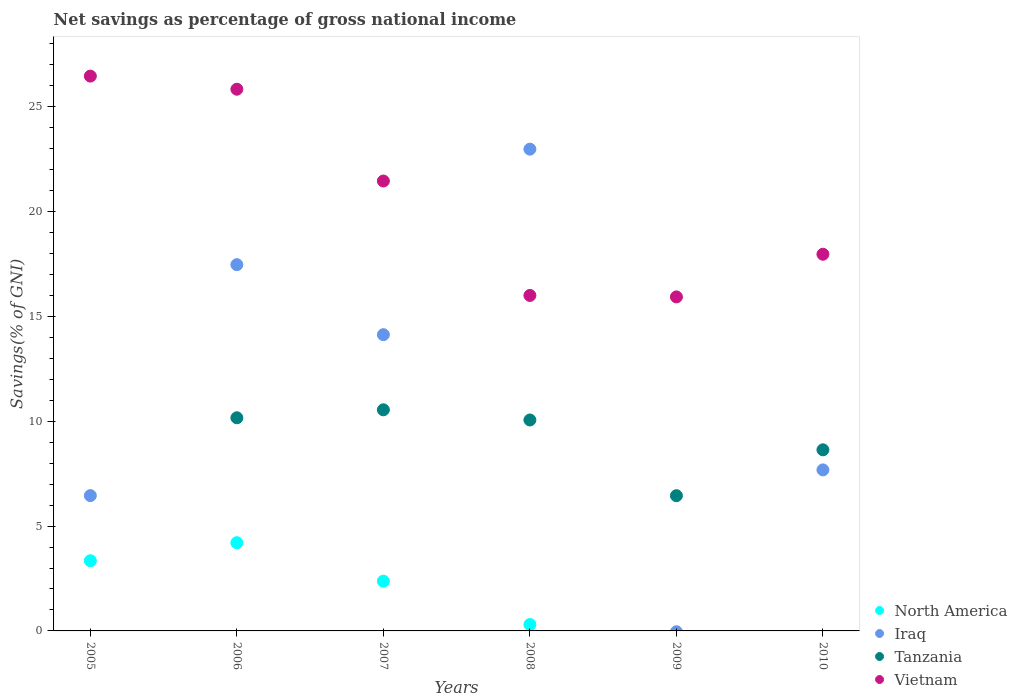What is the total savings in North America in 2007?
Give a very brief answer. 2.37. Across all years, what is the maximum total savings in Iraq?
Offer a very short reply. 22.98. Across all years, what is the minimum total savings in Vietnam?
Make the answer very short. 15.93. What is the total total savings in North America in the graph?
Your answer should be compact. 10.23. What is the difference between the total savings in Iraq in 2005 and that in 2006?
Offer a very short reply. -11.02. What is the difference between the total savings in Tanzania in 2005 and the total savings in Vietnam in 2007?
Keep it short and to the point. -21.46. What is the average total savings in North America per year?
Provide a succinct answer. 1.71. In the year 2006, what is the difference between the total savings in Tanzania and total savings in Vietnam?
Provide a succinct answer. -15.67. What is the ratio of the total savings in Vietnam in 2007 to that in 2008?
Give a very brief answer. 1.34. Is the total savings in Iraq in 2006 less than that in 2010?
Offer a terse response. No. What is the difference between the highest and the second highest total savings in Tanzania?
Your answer should be compact. 0.38. What is the difference between the highest and the lowest total savings in Iraq?
Provide a short and direct response. 22.98. In how many years, is the total savings in Vietnam greater than the average total savings in Vietnam taken over all years?
Your response must be concise. 3. Is it the case that in every year, the sum of the total savings in Vietnam and total savings in Iraq  is greater than the sum of total savings in Tanzania and total savings in North America?
Ensure brevity in your answer.  No. Is it the case that in every year, the sum of the total savings in Iraq and total savings in Vietnam  is greater than the total savings in Tanzania?
Offer a terse response. Yes. Is the total savings in Tanzania strictly less than the total savings in Vietnam over the years?
Your answer should be compact. Yes. How many years are there in the graph?
Give a very brief answer. 6. Does the graph contain any zero values?
Ensure brevity in your answer.  Yes. Does the graph contain grids?
Keep it short and to the point. No. How many legend labels are there?
Provide a succinct answer. 4. How are the legend labels stacked?
Provide a short and direct response. Vertical. What is the title of the graph?
Your answer should be very brief. Net savings as percentage of gross national income. What is the label or title of the X-axis?
Offer a very short reply. Years. What is the label or title of the Y-axis?
Your answer should be very brief. Savings(% of GNI). What is the Savings(% of GNI) in North America in 2005?
Ensure brevity in your answer.  3.35. What is the Savings(% of GNI) in Iraq in 2005?
Give a very brief answer. 6.45. What is the Savings(% of GNI) in Tanzania in 2005?
Make the answer very short. 0. What is the Savings(% of GNI) of Vietnam in 2005?
Ensure brevity in your answer.  26.46. What is the Savings(% of GNI) of North America in 2006?
Provide a short and direct response. 4.21. What is the Savings(% of GNI) in Iraq in 2006?
Provide a succinct answer. 17.47. What is the Savings(% of GNI) in Tanzania in 2006?
Offer a terse response. 10.17. What is the Savings(% of GNI) of Vietnam in 2006?
Offer a terse response. 25.84. What is the Savings(% of GNI) of North America in 2007?
Offer a terse response. 2.37. What is the Savings(% of GNI) of Iraq in 2007?
Your response must be concise. 14.13. What is the Savings(% of GNI) in Tanzania in 2007?
Your answer should be compact. 10.55. What is the Savings(% of GNI) in Vietnam in 2007?
Provide a short and direct response. 21.46. What is the Savings(% of GNI) of North America in 2008?
Make the answer very short. 0.3. What is the Savings(% of GNI) of Iraq in 2008?
Your answer should be very brief. 22.98. What is the Savings(% of GNI) in Tanzania in 2008?
Provide a short and direct response. 10.06. What is the Savings(% of GNI) of Vietnam in 2008?
Your answer should be compact. 16. What is the Savings(% of GNI) in North America in 2009?
Your response must be concise. 0. What is the Savings(% of GNI) of Iraq in 2009?
Keep it short and to the point. 0. What is the Savings(% of GNI) in Tanzania in 2009?
Give a very brief answer. 6.45. What is the Savings(% of GNI) of Vietnam in 2009?
Give a very brief answer. 15.93. What is the Savings(% of GNI) in North America in 2010?
Provide a short and direct response. 0. What is the Savings(% of GNI) of Iraq in 2010?
Provide a short and direct response. 7.68. What is the Savings(% of GNI) in Tanzania in 2010?
Your answer should be very brief. 8.64. What is the Savings(% of GNI) in Vietnam in 2010?
Provide a short and direct response. 17.97. Across all years, what is the maximum Savings(% of GNI) of North America?
Your response must be concise. 4.21. Across all years, what is the maximum Savings(% of GNI) of Iraq?
Ensure brevity in your answer.  22.98. Across all years, what is the maximum Savings(% of GNI) of Tanzania?
Keep it short and to the point. 10.55. Across all years, what is the maximum Savings(% of GNI) of Vietnam?
Offer a very short reply. 26.46. Across all years, what is the minimum Savings(% of GNI) in Iraq?
Your response must be concise. 0. Across all years, what is the minimum Savings(% of GNI) of Tanzania?
Your answer should be very brief. 0. Across all years, what is the minimum Savings(% of GNI) of Vietnam?
Provide a succinct answer. 15.93. What is the total Savings(% of GNI) in North America in the graph?
Your answer should be very brief. 10.23. What is the total Savings(% of GNI) of Iraq in the graph?
Give a very brief answer. 68.72. What is the total Savings(% of GNI) of Tanzania in the graph?
Provide a succinct answer. 45.86. What is the total Savings(% of GNI) of Vietnam in the graph?
Make the answer very short. 123.66. What is the difference between the Savings(% of GNI) in North America in 2005 and that in 2006?
Your answer should be very brief. -0.86. What is the difference between the Savings(% of GNI) of Iraq in 2005 and that in 2006?
Provide a succinct answer. -11.02. What is the difference between the Savings(% of GNI) of Vietnam in 2005 and that in 2006?
Your response must be concise. 0.63. What is the difference between the Savings(% of GNI) of North America in 2005 and that in 2007?
Your response must be concise. 0.97. What is the difference between the Savings(% of GNI) in Iraq in 2005 and that in 2007?
Offer a very short reply. -7.68. What is the difference between the Savings(% of GNI) in Vietnam in 2005 and that in 2007?
Offer a very short reply. 5. What is the difference between the Savings(% of GNI) in North America in 2005 and that in 2008?
Your answer should be compact. 3.04. What is the difference between the Savings(% of GNI) of Iraq in 2005 and that in 2008?
Give a very brief answer. -16.53. What is the difference between the Savings(% of GNI) of Vietnam in 2005 and that in 2008?
Make the answer very short. 10.46. What is the difference between the Savings(% of GNI) in Vietnam in 2005 and that in 2009?
Provide a short and direct response. 10.53. What is the difference between the Savings(% of GNI) of Iraq in 2005 and that in 2010?
Offer a terse response. -1.23. What is the difference between the Savings(% of GNI) in Vietnam in 2005 and that in 2010?
Make the answer very short. 8.5. What is the difference between the Savings(% of GNI) of North America in 2006 and that in 2007?
Make the answer very short. 1.83. What is the difference between the Savings(% of GNI) in Iraq in 2006 and that in 2007?
Your response must be concise. 3.34. What is the difference between the Savings(% of GNI) of Tanzania in 2006 and that in 2007?
Provide a succinct answer. -0.38. What is the difference between the Savings(% of GNI) of Vietnam in 2006 and that in 2007?
Provide a short and direct response. 4.38. What is the difference between the Savings(% of GNI) of North America in 2006 and that in 2008?
Give a very brief answer. 3.9. What is the difference between the Savings(% of GNI) of Iraq in 2006 and that in 2008?
Offer a very short reply. -5.51. What is the difference between the Savings(% of GNI) in Tanzania in 2006 and that in 2008?
Give a very brief answer. 0.1. What is the difference between the Savings(% of GNI) of Vietnam in 2006 and that in 2008?
Provide a short and direct response. 9.84. What is the difference between the Savings(% of GNI) of Tanzania in 2006 and that in 2009?
Provide a short and direct response. 3.72. What is the difference between the Savings(% of GNI) of Vietnam in 2006 and that in 2009?
Offer a very short reply. 9.91. What is the difference between the Savings(% of GNI) in Iraq in 2006 and that in 2010?
Offer a very short reply. 9.79. What is the difference between the Savings(% of GNI) in Tanzania in 2006 and that in 2010?
Your response must be concise. 1.53. What is the difference between the Savings(% of GNI) of Vietnam in 2006 and that in 2010?
Your answer should be very brief. 7.87. What is the difference between the Savings(% of GNI) of North America in 2007 and that in 2008?
Ensure brevity in your answer.  2.07. What is the difference between the Savings(% of GNI) of Iraq in 2007 and that in 2008?
Offer a very short reply. -8.85. What is the difference between the Savings(% of GNI) in Tanzania in 2007 and that in 2008?
Offer a terse response. 0.49. What is the difference between the Savings(% of GNI) in Vietnam in 2007 and that in 2008?
Make the answer very short. 5.46. What is the difference between the Savings(% of GNI) in Tanzania in 2007 and that in 2009?
Keep it short and to the point. 4.1. What is the difference between the Savings(% of GNI) in Vietnam in 2007 and that in 2009?
Make the answer very short. 5.53. What is the difference between the Savings(% of GNI) of Iraq in 2007 and that in 2010?
Provide a short and direct response. 6.45. What is the difference between the Savings(% of GNI) of Tanzania in 2007 and that in 2010?
Keep it short and to the point. 1.91. What is the difference between the Savings(% of GNI) of Vietnam in 2007 and that in 2010?
Make the answer very short. 3.49. What is the difference between the Savings(% of GNI) in Tanzania in 2008 and that in 2009?
Provide a succinct answer. 3.61. What is the difference between the Savings(% of GNI) in Vietnam in 2008 and that in 2009?
Provide a short and direct response. 0.07. What is the difference between the Savings(% of GNI) of Iraq in 2008 and that in 2010?
Ensure brevity in your answer.  15.3. What is the difference between the Savings(% of GNI) in Tanzania in 2008 and that in 2010?
Ensure brevity in your answer.  1.42. What is the difference between the Savings(% of GNI) of Vietnam in 2008 and that in 2010?
Make the answer very short. -1.97. What is the difference between the Savings(% of GNI) in Tanzania in 2009 and that in 2010?
Offer a terse response. -2.19. What is the difference between the Savings(% of GNI) of Vietnam in 2009 and that in 2010?
Offer a very short reply. -2.04. What is the difference between the Savings(% of GNI) in North America in 2005 and the Savings(% of GNI) in Iraq in 2006?
Your response must be concise. -14.12. What is the difference between the Savings(% of GNI) of North America in 2005 and the Savings(% of GNI) of Tanzania in 2006?
Keep it short and to the point. -6.82. What is the difference between the Savings(% of GNI) of North America in 2005 and the Savings(% of GNI) of Vietnam in 2006?
Give a very brief answer. -22.49. What is the difference between the Savings(% of GNI) of Iraq in 2005 and the Savings(% of GNI) of Tanzania in 2006?
Your answer should be very brief. -3.71. What is the difference between the Savings(% of GNI) in Iraq in 2005 and the Savings(% of GNI) in Vietnam in 2006?
Offer a terse response. -19.38. What is the difference between the Savings(% of GNI) in North America in 2005 and the Savings(% of GNI) in Iraq in 2007?
Your answer should be compact. -10.78. What is the difference between the Savings(% of GNI) of North America in 2005 and the Savings(% of GNI) of Tanzania in 2007?
Offer a terse response. -7.2. What is the difference between the Savings(% of GNI) of North America in 2005 and the Savings(% of GNI) of Vietnam in 2007?
Give a very brief answer. -18.11. What is the difference between the Savings(% of GNI) of Iraq in 2005 and the Savings(% of GNI) of Tanzania in 2007?
Provide a succinct answer. -4.09. What is the difference between the Savings(% of GNI) of Iraq in 2005 and the Savings(% of GNI) of Vietnam in 2007?
Offer a very short reply. -15.01. What is the difference between the Savings(% of GNI) in North America in 2005 and the Savings(% of GNI) in Iraq in 2008?
Make the answer very short. -19.63. What is the difference between the Savings(% of GNI) in North America in 2005 and the Savings(% of GNI) in Tanzania in 2008?
Provide a succinct answer. -6.71. What is the difference between the Savings(% of GNI) in North America in 2005 and the Savings(% of GNI) in Vietnam in 2008?
Offer a very short reply. -12.65. What is the difference between the Savings(% of GNI) in Iraq in 2005 and the Savings(% of GNI) in Tanzania in 2008?
Your answer should be very brief. -3.61. What is the difference between the Savings(% of GNI) of Iraq in 2005 and the Savings(% of GNI) of Vietnam in 2008?
Ensure brevity in your answer.  -9.55. What is the difference between the Savings(% of GNI) of North America in 2005 and the Savings(% of GNI) of Tanzania in 2009?
Your response must be concise. -3.1. What is the difference between the Savings(% of GNI) of North America in 2005 and the Savings(% of GNI) of Vietnam in 2009?
Give a very brief answer. -12.58. What is the difference between the Savings(% of GNI) in Iraq in 2005 and the Savings(% of GNI) in Tanzania in 2009?
Ensure brevity in your answer.  0. What is the difference between the Savings(% of GNI) in Iraq in 2005 and the Savings(% of GNI) in Vietnam in 2009?
Your answer should be compact. -9.48. What is the difference between the Savings(% of GNI) in North America in 2005 and the Savings(% of GNI) in Iraq in 2010?
Offer a terse response. -4.33. What is the difference between the Savings(% of GNI) in North America in 2005 and the Savings(% of GNI) in Tanzania in 2010?
Offer a terse response. -5.29. What is the difference between the Savings(% of GNI) in North America in 2005 and the Savings(% of GNI) in Vietnam in 2010?
Give a very brief answer. -14.62. What is the difference between the Savings(% of GNI) in Iraq in 2005 and the Savings(% of GNI) in Tanzania in 2010?
Your answer should be very brief. -2.18. What is the difference between the Savings(% of GNI) of Iraq in 2005 and the Savings(% of GNI) of Vietnam in 2010?
Keep it short and to the point. -11.51. What is the difference between the Savings(% of GNI) of North America in 2006 and the Savings(% of GNI) of Iraq in 2007?
Your response must be concise. -9.92. What is the difference between the Savings(% of GNI) in North America in 2006 and the Savings(% of GNI) in Tanzania in 2007?
Your answer should be very brief. -6.34. What is the difference between the Savings(% of GNI) in North America in 2006 and the Savings(% of GNI) in Vietnam in 2007?
Make the answer very short. -17.25. What is the difference between the Savings(% of GNI) in Iraq in 2006 and the Savings(% of GNI) in Tanzania in 2007?
Provide a short and direct response. 6.92. What is the difference between the Savings(% of GNI) of Iraq in 2006 and the Savings(% of GNI) of Vietnam in 2007?
Make the answer very short. -3.99. What is the difference between the Savings(% of GNI) in Tanzania in 2006 and the Savings(% of GNI) in Vietnam in 2007?
Ensure brevity in your answer.  -11.29. What is the difference between the Savings(% of GNI) of North America in 2006 and the Savings(% of GNI) of Iraq in 2008?
Give a very brief answer. -18.77. What is the difference between the Savings(% of GNI) of North America in 2006 and the Savings(% of GNI) of Tanzania in 2008?
Make the answer very short. -5.86. What is the difference between the Savings(% of GNI) of North America in 2006 and the Savings(% of GNI) of Vietnam in 2008?
Ensure brevity in your answer.  -11.8. What is the difference between the Savings(% of GNI) of Iraq in 2006 and the Savings(% of GNI) of Tanzania in 2008?
Keep it short and to the point. 7.41. What is the difference between the Savings(% of GNI) in Iraq in 2006 and the Savings(% of GNI) in Vietnam in 2008?
Ensure brevity in your answer.  1.47. What is the difference between the Savings(% of GNI) in Tanzania in 2006 and the Savings(% of GNI) in Vietnam in 2008?
Your answer should be compact. -5.84. What is the difference between the Savings(% of GNI) of North America in 2006 and the Savings(% of GNI) of Tanzania in 2009?
Provide a short and direct response. -2.24. What is the difference between the Savings(% of GNI) of North America in 2006 and the Savings(% of GNI) of Vietnam in 2009?
Your answer should be very brief. -11.72. What is the difference between the Savings(% of GNI) of Iraq in 2006 and the Savings(% of GNI) of Tanzania in 2009?
Provide a short and direct response. 11.02. What is the difference between the Savings(% of GNI) in Iraq in 2006 and the Savings(% of GNI) in Vietnam in 2009?
Keep it short and to the point. 1.54. What is the difference between the Savings(% of GNI) in Tanzania in 2006 and the Savings(% of GNI) in Vietnam in 2009?
Keep it short and to the point. -5.77. What is the difference between the Savings(% of GNI) of North America in 2006 and the Savings(% of GNI) of Iraq in 2010?
Offer a very short reply. -3.47. What is the difference between the Savings(% of GNI) in North America in 2006 and the Savings(% of GNI) in Tanzania in 2010?
Your answer should be very brief. -4.43. What is the difference between the Savings(% of GNI) in North America in 2006 and the Savings(% of GNI) in Vietnam in 2010?
Give a very brief answer. -13.76. What is the difference between the Savings(% of GNI) in Iraq in 2006 and the Savings(% of GNI) in Tanzania in 2010?
Give a very brief answer. 8.83. What is the difference between the Savings(% of GNI) in Iraq in 2006 and the Savings(% of GNI) in Vietnam in 2010?
Provide a short and direct response. -0.5. What is the difference between the Savings(% of GNI) of Tanzania in 2006 and the Savings(% of GNI) of Vietnam in 2010?
Keep it short and to the point. -7.8. What is the difference between the Savings(% of GNI) of North America in 2007 and the Savings(% of GNI) of Iraq in 2008?
Offer a very short reply. -20.61. What is the difference between the Savings(% of GNI) of North America in 2007 and the Savings(% of GNI) of Tanzania in 2008?
Provide a succinct answer. -7.69. What is the difference between the Savings(% of GNI) in North America in 2007 and the Savings(% of GNI) in Vietnam in 2008?
Your answer should be very brief. -13.63. What is the difference between the Savings(% of GNI) of Iraq in 2007 and the Savings(% of GNI) of Tanzania in 2008?
Provide a succinct answer. 4.07. What is the difference between the Savings(% of GNI) of Iraq in 2007 and the Savings(% of GNI) of Vietnam in 2008?
Your answer should be compact. -1.87. What is the difference between the Savings(% of GNI) of Tanzania in 2007 and the Savings(% of GNI) of Vietnam in 2008?
Make the answer very short. -5.46. What is the difference between the Savings(% of GNI) in North America in 2007 and the Savings(% of GNI) in Tanzania in 2009?
Ensure brevity in your answer.  -4.08. What is the difference between the Savings(% of GNI) in North America in 2007 and the Savings(% of GNI) in Vietnam in 2009?
Offer a terse response. -13.56. What is the difference between the Savings(% of GNI) of Iraq in 2007 and the Savings(% of GNI) of Tanzania in 2009?
Your answer should be compact. 7.68. What is the difference between the Savings(% of GNI) of Iraq in 2007 and the Savings(% of GNI) of Vietnam in 2009?
Offer a terse response. -1.8. What is the difference between the Savings(% of GNI) of Tanzania in 2007 and the Savings(% of GNI) of Vietnam in 2009?
Keep it short and to the point. -5.38. What is the difference between the Savings(% of GNI) of North America in 2007 and the Savings(% of GNI) of Iraq in 2010?
Keep it short and to the point. -5.31. What is the difference between the Savings(% of GNI) of North America in 2007 and the Savings(% of GNI) of Tanzania in 2010?
Offer a very short reply. -6.26. What is the difference between the Savings(% of GNI) of North America in 2007 and the Savings(% of GNI) of Vietnam in 2010?
Make the answer very short. -15.59. What is the difference between the Savings(% of GNI) in Iraq in 2007 and the Savings(% of GNI) in Tanzania in 2010?
Your response must be concise. 5.49. What is the difference between the Savings(% of GNI) in Iraq in 2007 and the Savings(% of GNI) in Vietnam in 2010?
Ensure brevity in your answer.  -3.84. What is the difference between the Savings(% of GNI) of Tanzania in 2007 and the Savings(% of GNI) of Vietnam in 2010?
Offer a very short reply. -7.42. What is the difference between the Savings(% of GNI) in North America in 2008 and the Savings(% of GNI) in Tanzania in 2009?
Offer a terse response. -6.15. What is the difference between the Savings(% of GNI) of North America in 2008 and the Savings(% of GNI) of Vietnam in 2009?
Give a very brief answer. -15.63. What is the difference between the Savings(% of GNI) in Iraq in 2008 and the Savings(% of GNI) in Tanzania in 2009?
Provide a succinct answer. 16.53. What is the difference between the Savings(% of GNI) of Iraq in 2008 and the Savings(% of GNI) of Vietnam in 2009?
Offer a very short reply. 7.05. What is the difference between the Savings(% of GNI) of Tanzania in 2008 and the Savings(% of GNI) of Vietnam in 2009?
Provide a succinct answer. -5.87. What is the difference between the Savings(% of GNI) in North America in 2008 and the Savings(% of GNI) in Iraq in 2010?
Provide a succinct answer. -7.38. What is the difference between the Savings(% of GNI) of North America in 2008 and the Savings(% of GNI) of Tanzania in 2010?
Offer a terse response. -8.33. What is the difference between the Savings(% of GNI) in North America in 2008 and the Savings(% of GNI) in Vietnam in 2010?
Your response must be concise. -17.66. What is the difference between the Savings(% of GNI) in Iraq in 2008 and the Savings(% of GNI) in Tanzania in 2010?
Give a very brief answer. 14.34. What is the difference between the Savings(% of GNI) of Iraq in 2008 and the Savings(% of GNI) of Vietnam in 2010?
Your answer should be very brief. 5.01. What is the difference between the Savings(% of GNI) in Tanzania in 2008 and the Savings(% of GNI) in Vietnam in 2010?
Keep it short and to the point. -7.91. What is the difference between the Savings(% of GNI) of Tanzania in 2009 and the Savings(% of GNI) of Vietnam in 2010?
Your response must be concise. -11.52. What is the average Savings(% of GNI) of North America per year?
Your response must be concise. 1.71. What is the average Savings(% of GNI) in Iraq per year?
Your answer should be very brief. 11.45. What is the average Savings(% of GNI) in Tanzania per year?
Ensure brevity in your answer.  7.64. What is the average Savings(% of GNI) of Vietnam per year?
Your answer should be very brief. 20.61. In the year 2005, what is the difference between the Savings(% of GNI) in North America and Savings(% of GNI) in Iraq?
Make the answer very short. -3.11. In the year 2005, what is the difference between the Savings(% of GNI) in North America and Savings(% of GNI) in Vietnam?
Your answer should be compact. -23.12. In the year 2005, what is the difference between the Savings(% of GNI) in Iraq and Savings(% of GNI) in Vietnam?
Your answer should be very brief. -20.01. In the year 2006, what is the difference between the Savings(% of GNI) of North America and Savings(% of GNI) of Iraq?
Offer a very short reply. -13.26. In the year 2006, what is the difference between the Savings(% of GNI) in North America and Savings(% of GNI) in Tanzania?
Your response must be concise. -5.96. In the year 2006, what is the difference between the Savings(% of GNI) of North America and Savings(% of GNI) of Vietnam?
Your answer should be compact. -21.63. In the year 2006, what is the difference between the Savings(% of GNI) of Iraq and Savings(% of GNI) of Tanzania?
Make the answer very short. 7.3. In the year 2006, what is the difference between the Savings(% of GNI) in Iraq and Savings(% of GNI) in Vietnam?
Offer a terse response. -8.37. In the year 2006, what is the difference between the Savings(% of GNI) in Tanzania and Savings(% of GNI) in Vietnam?
Provide a succinct answer. -15.67. In the year 2007, what is the difference between the Savings(% of GNI) of North America and Savings(% of GNI) of Iraq?
Offer a very short reply. -11.76. In the year 2007, what is the difference between the Savings(% of GNI) in North America and Savings(% of GNI) in Tanzania?
Offer a terse response. -8.17. In the year 2007, what is the difference between the Savings(% of GNI) in North America and Savings(% of GNI) in Vietnam?
Ensure brevity in your answer.  -19.09. In the year 2007, what is the difference between the Savings(% of GNI) of Iraq and Savings(% of GNI) of Tanzania?
Give a very brief answer. 3.58. In the year 2007, what is the difference between the Savings(% of GNI) in Iraq and Savings(% of GNI) in Vietnam?
Provide a short and direct response. -7.33. In the year 2007, what is the difference between the Savings(% of GNI) in Tanzania and Savings(% of GNI) in Vietnam?
Keep it short and to the point. -10.91. In the year 2008, what is the difference between the Savings(% of GNI) in North America and Savings(% of GNI) in Iraq?
Your answer should be very brief. -22.68. In the year 2008, what is the difference between the Savings(% of GNI) of North America and Savings(% of GNI) of Tanzania?
Offer a terse response. -9.76. In the year 2008, what is the difference between the Savings(% of GNI) of North America and Savings(% of GNI) of Vietnam?
Your response must be concise. -15.7. In the year 2008, what is the difference between the Savings(% of GNI) in Iraq and Savings(% of GNI) in Tanzania?
Ensure brevity in your answer.  12.92. In the year 2008, what is the difference between the Savings(% of GNI) in Iraq and Savings(% of GNI) in Vietnam?
Ensure brevity in your answer.  6.98. In the year 2008, what is the difference between the Savings(% of GNI) of Tanzania and Savings(% of GNI) of Vietnam?
Keep it short and to the point. -5.94. In the year 2009, what is the difference between the Savings(% of GNI) in Tanzania and Savings(% of GNI) in Vietnam?
Your answer should be compact. -9.48. In the year 2010, what is the difference between the Savings(% of GNI) of Iraq and Savings(% of GNI) of Tanzania?
Give a very brief answer. -0.96. In the year 2010, what is the difference between the Savings(% of GNI) in Iraq and Savings(% of GNI) in Vietnam?
Provide a succinct answer. -10.29. In the year 2010, what is the difference between the Savings(% of GNI) in Tanzania and Savings(% of GNI) in Vietnam?
Your response must be concise. -9.33. What is the ratio of the Savings(% of GNI) in North America in 2005 to that in 2006?
Provide a short and direct response. 0.8. What is the ratio of the Savings(% of GNI) in Iraq in 2005 to that in 2006?
Ensure brevity in your answer.  0.37. What is the ratio of the Savings(% of GNI) of Vietnam in 2005 to that in 2006?
Your response must be concise. 1.02. What is the ratio of the Savings(% of GNI) in North America in 2005 to that in 2007?
Make the answer very short. 1.41. What is the ratio of the Savings(% of GNI) in Iraq in 2005 to that in 2007?
Ensure brevity in your answer.  0.46. What is the ratio of the Savings(% of GNI) of Vietnam in 2005 to that in 2007?
Provide a short and direct response. 1.23. What is the ratio of the Savings(% of GNI) in North America in 2005 to that in 2008?
Your answer should be very brief. 10.99. What is the ratio of the Savings(% of GNI) of Iraq in 2005 to that in 2008?
Your answer should be compact. 0.28. What is the ratio of the Savings(% of GNI) in Vietnam in 2005 to that in 2008?
Provide a succinct answer. 1.65. What is the ratio of the Savings(% of GNI) in Vietnam in 2005 to that in 2009?
Your answer should be compact. 1.66. What is the ratio of the Savings(% of GNI) of Iraq in 2005 to that in 2010?
Make the answer very short. 0.84. What is the ratio of the Savings(% of GNI) in Vietnam in 2005 to that in 2010?
Offer a very short reply. 1.47. What is the ratio of the Savings(% of GNI) of North America in 2006 to that in 2007?
Make the answer very short. 1.77. What is the ratio of the Savings(% of GNI) of Iraq in 2006 to that in 2007?
Give a very brief answer. 1.24. What is the ratio of the Savings(% of GNI) in Tanzania in 2006 to that in 2007?
Your answer should be very brief. 0.96. What is the ratio of the Savings(% of GNI) of Vietnam in 2006 to that in 2007?
Keep it short and to the point. 1.2. What is the ratio of the Savings(% of GNI) in North America in 2006 to that in 2008?
Your answer should be compact. 13.81. What is the ratio of the Savings(% of GNI) in Iraq in 2006 to that in 2008?
Keep it short and to the point. 0.76. What is the ratio of the Savings(% of GNI) of Tanzania in 2006 to that in 2008?
Your response must be concise. 1.01. What is the ratio of the Savings(% of GNI) in Vietnam in 2006 to that in 2008?
Provide a succinct answer. 1.61. What is the ratio of the Savings(% of GNI) in Tanzania in 2006 to that in 2009?
Give a very brief answer. 1.58. What is the ratio of the Savings(% of GNI) in Vietnam in 2006 to that in 2009?
Your answer should be very brief. 1.62. What is the ratio of the Savings(% of GNI) in Iraq in 2006 to that in 2010?
Your answer should be compact. 2.27. What is the ratio of the Savings(% of GNI) of Tanzania in 2006 to that in 2010?
Your response must be concise. 1.18. What is the ratio of the Savings(% of GNI) in Vietnam in 2006 to that in 2010?
Offer a terse response. 1.44. What is the ratio of the Savings(% of GNI) in North America in 2007 to that in 2008?
Your answer should be very brief. 7.79. What is the ratio of the Savings(% of GNI) of Iraq in 2007 to that in 2008?
Ensure brevity in your answer.  0.61. What is the ratio of the Savings(% of GNI) of Tanzania in 2007 to that in 2008?
Your answer should be compact. 1.05. What is the ratio of the Savings(% of GNI) in Vietnam in 2007 to that in 2008?
Keep it short and to the point. 1.34. What is the ratio of the Savings(% of GNI) of Tanzania in 2007 to that in 2009?
Ensure brevity in your answer.  1.64. What is the ratio of the Savings(% of GNI) in Vietnam in 2007 to that in 2009?
Offer a very short reply. 1.35. What is the ratio of the Savings(% of GNI) of Iraq in 2007 to that in 2010?
Ensure brevity in your answer.  1.84. What is the ratio of the Savings(% of GNI) of Tanzania in 2007 to that in 2010?
Offer a terse response. 1.22. What is the ratio of the Savings(% of GNI) in Vietnam in 2007 to that in 2010?
Offer a terse response. 1.19. What is the ratio of the Savings(% of GNI) in Tanzania in 2008 to that in 2009?
Offer a terse response. 1.56. What is the ratio of the Savings(% of GNI) of Vietnam in 2008 to that in 2009?
Provide a succinct answer. 1. What is the ratio of the Savings(% of GNI) in Iraq in 2008 to that in 2010?
Give a very brief answer. 2.99. What is the ratio of the Savings(% of GNI) in Tanzania in 2008 to that in 2010?
Make the answer very short. 1.16. What is the ratio of the Savings(% of GNI) of Vietnam in 2008 to that in 2010?
Ensure brevity in your answer.  0.89. What is the ratio of the Savings(% of GNI) of Tanzania in 2009 to that in 2010?
Offer a very short reply. 0.75. What is the ratio of the Savings(% of GNI) in Vietnam in 2009 to that in 2010?
Provide a short and direct response. 0.89. What is the difference between the highest and the second highest Savings(% of GNI) in North America?
Provide a short and direct response. 0.86. What is the difference between the highest and the second highest Savings(% of GNI) of Iraq?
Provide a short and direct response. 5.51. What is the difference between the highest and the second highest Savings(% of GNI) of Tanzania?
Offer a terse response. 0.38. What is the difference between the highest and the second highest Savings(% of GNI) in Vietnam?
Your answer should be very brief. 0.63. What is the difference between the highest and the lowest Savings(% of GNI) of North America?
Your answer should be very brief. 4.21. What is the difference between the highest and the lowest Savings(% of GNI) of Iraq?
Offer a terse response. 22.98. What is the difference between the highest and the lowest Savings(% of GNI) in Tanzania?
Provide a succinct answer. 10.55. What is the difference between the highest and the lowest Savings(% of GNI) in Vietnam?
Offer a terse response. 10.53. 